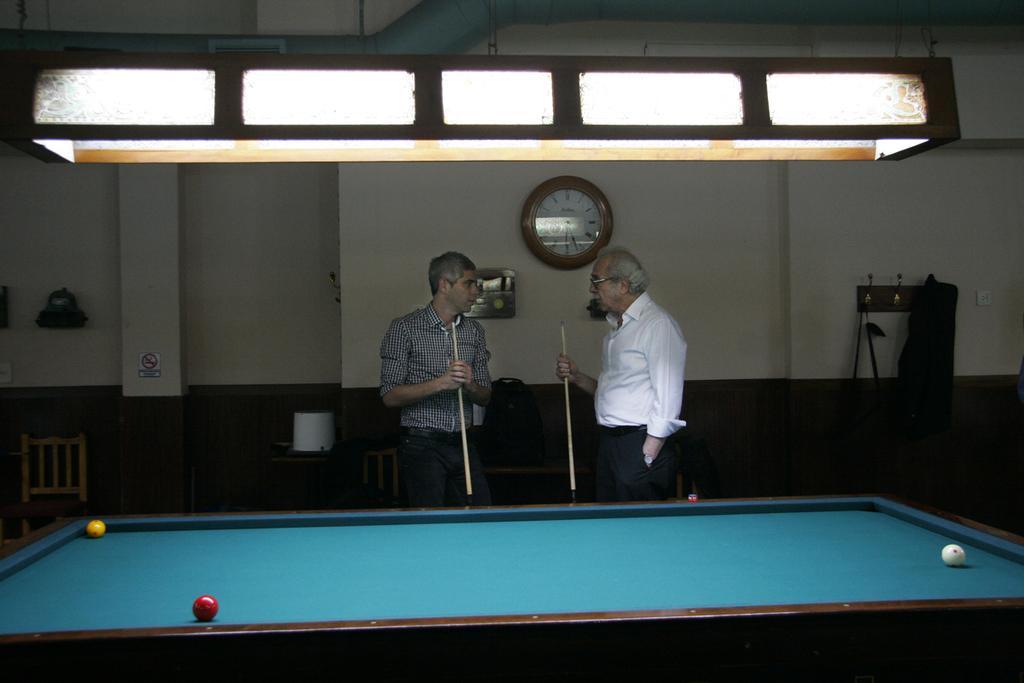Please provide a concise description of this image. In the image in the center we can see tennis table. On table,we can see three different color balls. And we can see two persons were standing and holding stick. In the background we can see wall,wall clock,hanger,cloth,bag,white color object,sign board,pillar,chair,lights and few other objects. 